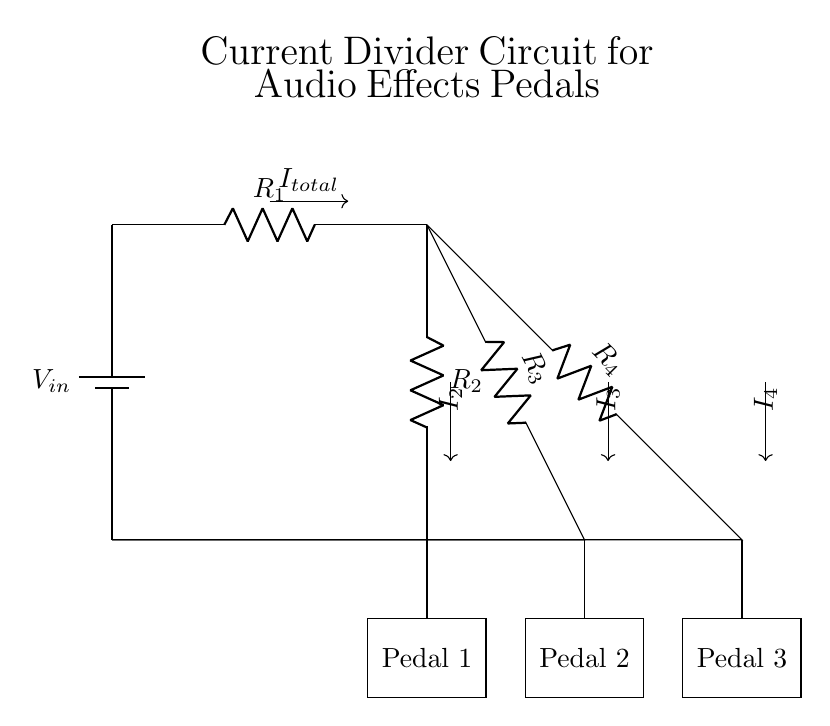What is the input voltage of the circuit? The circuit shows a power source denoted as V_in, indicating the input voltage, but the value is not given in the diagram.
Answer: V_in How many resistors are there in the circuit? The diagram displays three resistors labeled R_2, R_3, and R_4, in addition to the main resistor R_1. Counting these gives a total of four resistors.
Answer: 4 What is the total current entering the current divider? The total current entering the current divider is denoted by I_total at the top of the diagram, which indicates it is the sum of all currents flowing through the individual branches.
Answer: I_total Which pedal is connected to resistor R_4? The diagram shows that R_4 branches out towards the connection leading to Pedal 3 at the bottom. Therefore, Pedal 3 is connected to R_4.
Answer: Pedal 3 If the resistors R_2, R_3, and R_4 are equal, how is the current distributed among the pedals? Given that the resistors R_2, R_3, and R_4 are equal, the current will be divided equally among the three branches due to their equal resistance. This results in I_2, I_3, and I_4 being one-third of the total current entered.
Answer: Equal distribution Which resistor would allow the highest current if they have different values? The resistor with the lowest resistance value allows the highest current to flow according to Ohm's law and the current divider principle.
Answer: Lowest resistance 